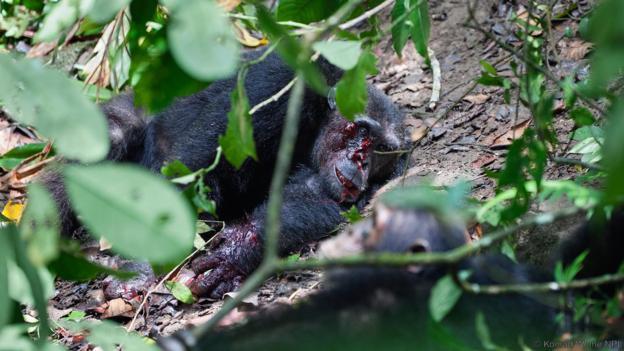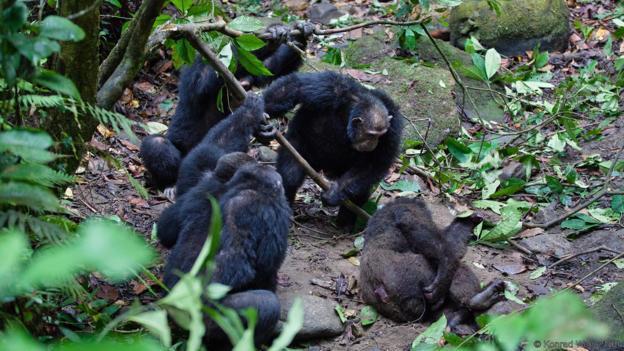The first image is the image on the left, the second image is the image on the right. For the images shown, is this caption "there is a single chimp holding animal parts" true? Answer yes or no. No. The first image is the image on the left, the second image is the image on the right. Examine the images to the left and right. Is the description "In one image there is a lone chimpanzee eating meat in the center of the image." accurate? Answer yes or no. No. 